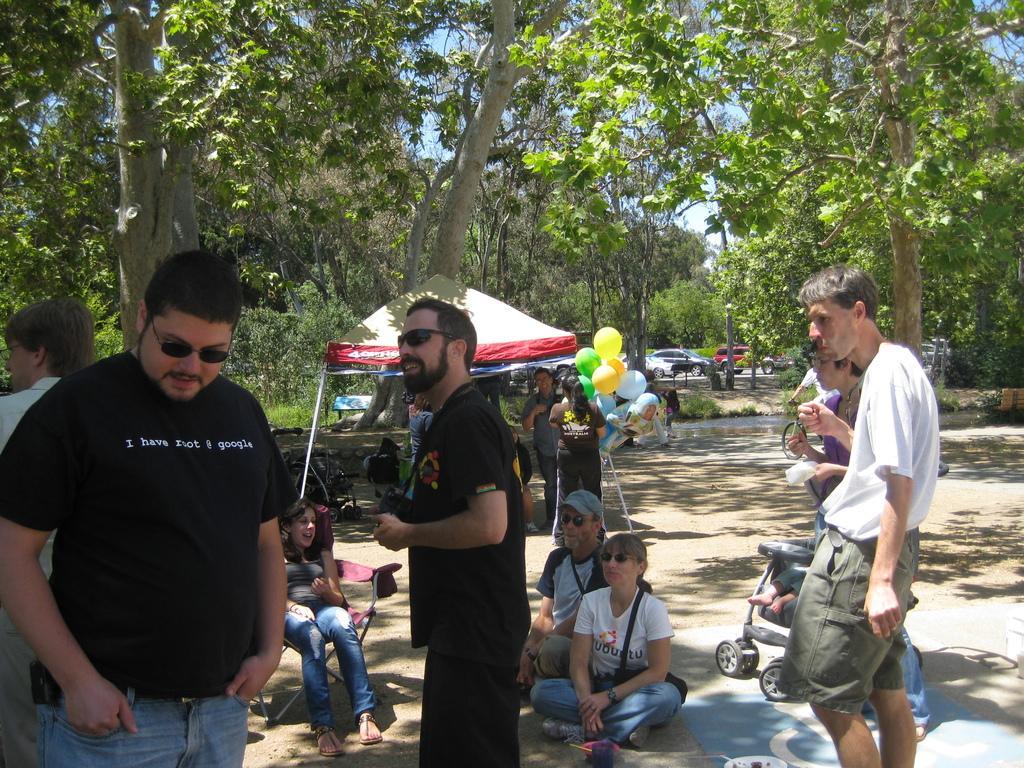Describe this image in one or two sentences. In this image we can see few people standing and few people sitting on the ground and a person is sitting on the chair and in the background there is a tent and few balloons, a person is riding a bicycle, there are cars on the road, few trees and the sky. 